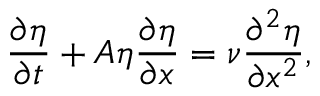Convert formula to latex. <formula><loc_0><loc_0><loc_500><loc_500>\frac { \partial \eta } { \partial t } + A \eta \frac { \partial \eta } { \partial x } = \nu \frac { \partial ^ { 2 } \eta } { \partial x ^ { 2 } } ,</formula> 